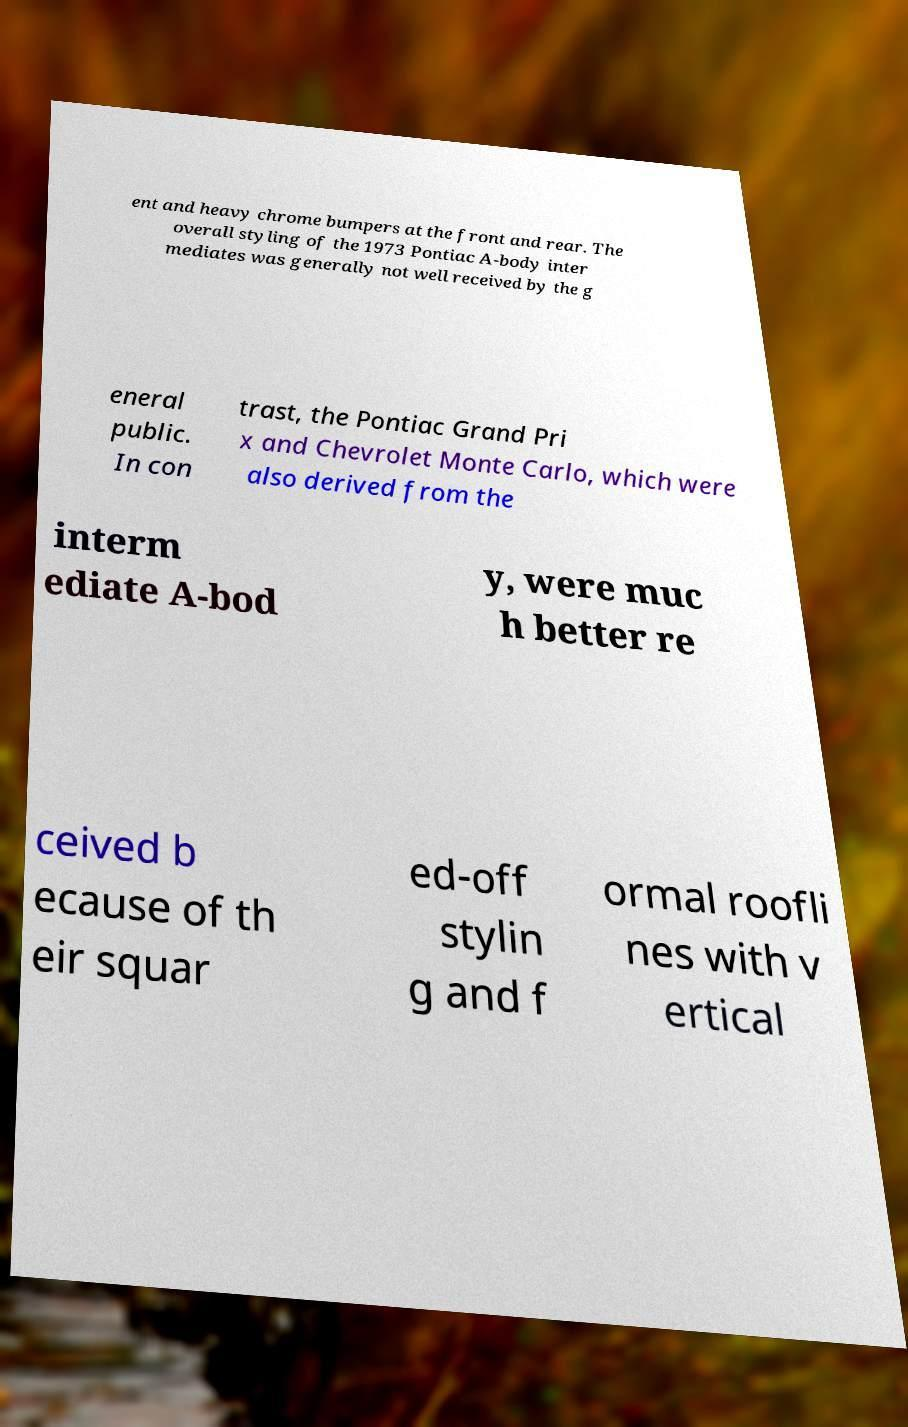What messages or text are displayed in this image? I need them in a readable, typed format. ent and heavy chrome bumpers at the front and rear. The overall styling of the 1973 Pontiac A-body inter mediates was generally not well received by the g eneral public. In con trast, the Pontiac Grand Pri x and Chevrolet Monte Carlo, which were also derived from the interm ediate A-bod y, were muc h better re ceived b ecause of th eir squar ed-off stylin g and f ormal roofli nes with v ertical 